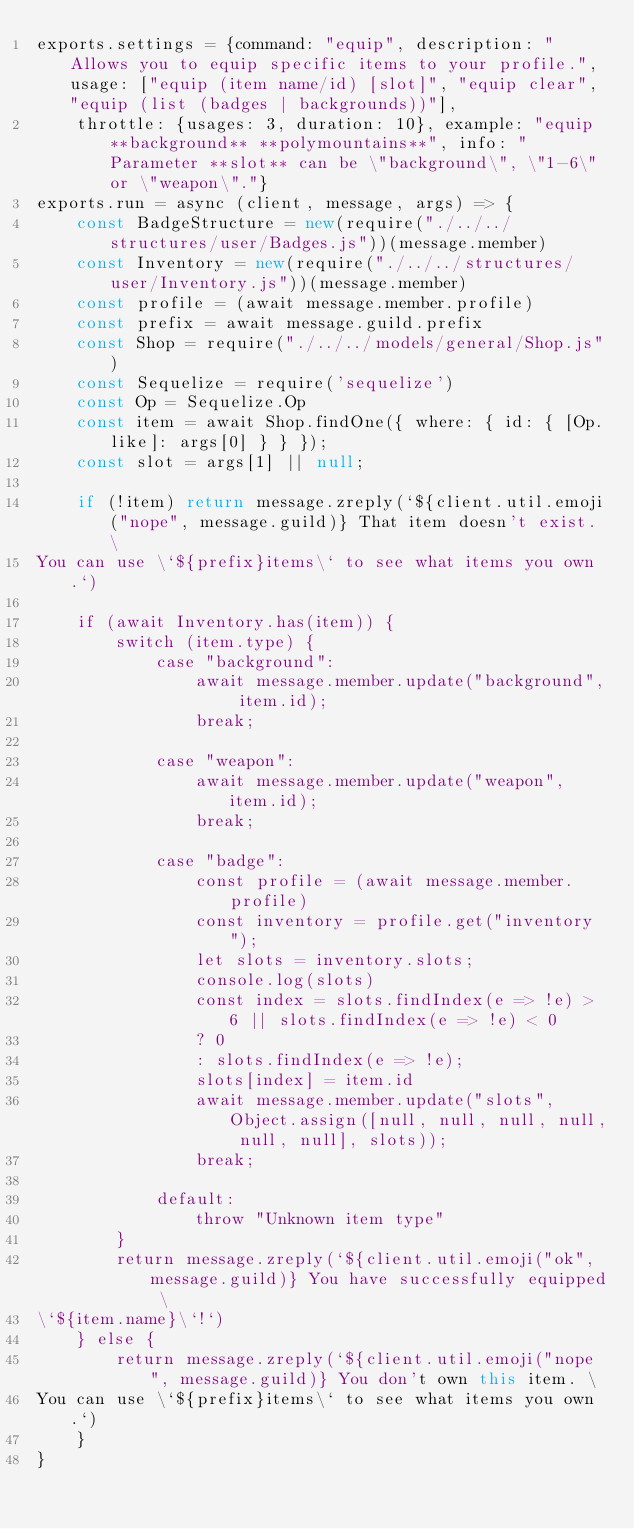Convert code to text. <code><loc_0><loc_0><loc_500><loc_500><_JavaScript_>exports.settings = {command: "equip", description: "Allows you to equip specific items to your profile.", usage: ["equip (item name/id) [slot]", "equip clear", "equip (list (badges | backgrounds))"],
	throttle: {usages: 3, duration: 10}, example: "equip **background** **polymountains**", info: "Parameter **slot** can be \"background\", \"1-6\" or \"weapon\"."}
exports.run = async (client, message, args) => {
	const BadgeStructure = new(require("./../../structures/user/Badges.js"))(message.member)
	const Inventory = new(require("./../../structures/user/Inventory.js"))(message.member)
	const profile = (await message.member.profile)
	const prefix = await message.guild.prefix
	const Shop = require("./../../models/general/Shop.js")
	const Sequelize = require('sequelize')
	const Op = Sequelize.Op
	const item = await Shop.findOne({ where: { id: { [Op.like]: args[0] } } });
	const slot = args[1] || null;

	if (!item) return message.zreply(`${client.util.emoji("nope", message.guild)} That item doesn't exist. \
You can use \`${prefix}items\` to see what items you own.`)

	if (await Inventory.has(item)) {
		switch (item.type) {
			case "background":
				await message.member.update("background", item.id);
				break;

			case "weapon":
				await message.member.update("weapon", item.id);
				break;

			case "badge":
				const profile = (await message.member.profile)
				const inventory = profile.get("inventory");
				let slots = inventory.slots;
				console.log(slots)
				const index = slots.findIndex(e => !e) > 6 || slots.findIndex(e => !e) < 0 
				? 0 
				: slots.findIndex(e => !e);
				slots[index] = item.id
				await message.member.update("slots", Object.assign([null, null, null, null, null, null], slots));
				break;

			default:
				throw "Unknown item type"
		}
		return message.zreply(`${client.util.emoji("ok", message.guild)} You have successfully equipped \
\`${item.name}\`!`)
	} else {
		return message.zreply(`${client.util.emoji("nope", message.guild)} You don't own this item. \
You can use \`${prefix}items\` to see what items you own.`)
	}
}
</code> 